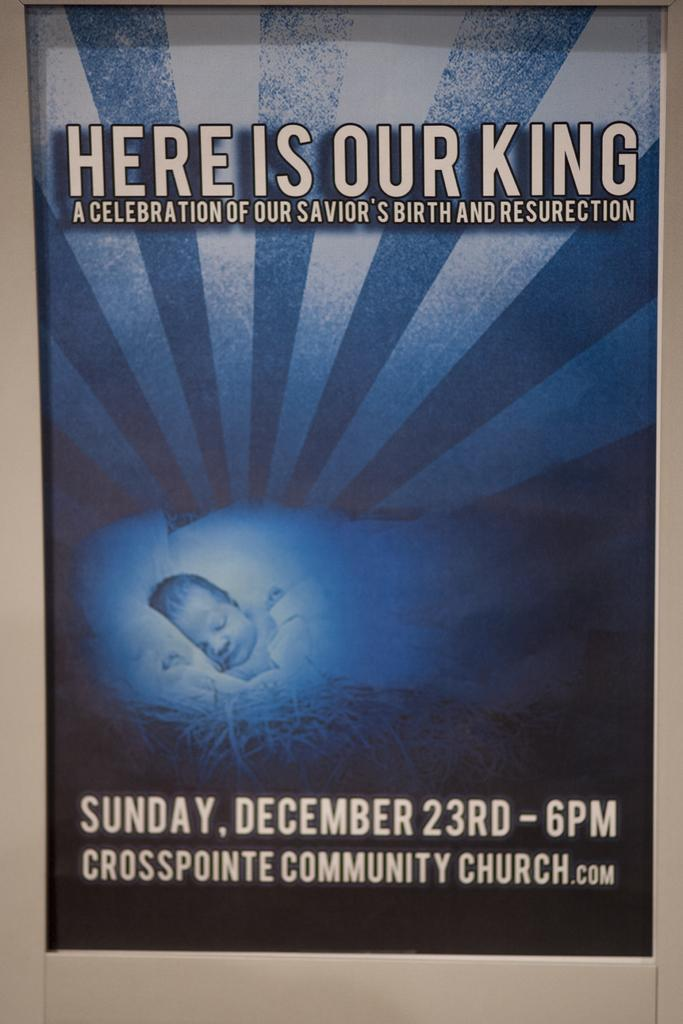What is present in the image that has text on it? There is a poster in the image that has text on it. Can you describe the poster in the image? The poster has text on it, but we cannot determine the specific content or design from the given facts. How many lizards can be seen crawling on the poster in the image? There are no lizards present in the image; the only subject mentioned is the poster with text on it. 